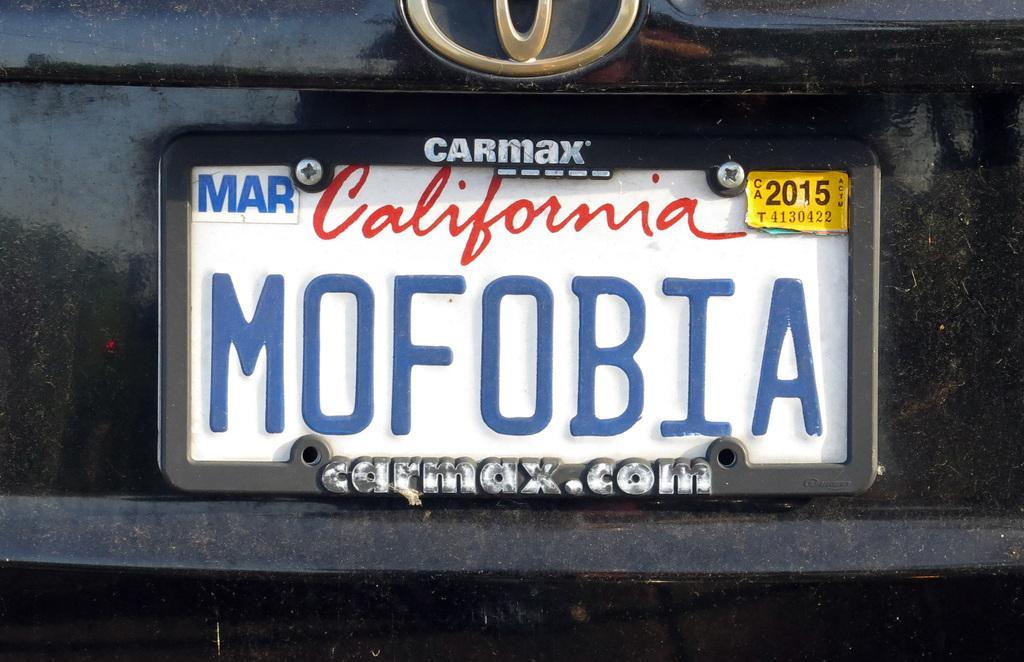Could you give a brief overview of what you see in this image? In this picture we can see a number plate with a sticker on it and a logo of a vehicle. 